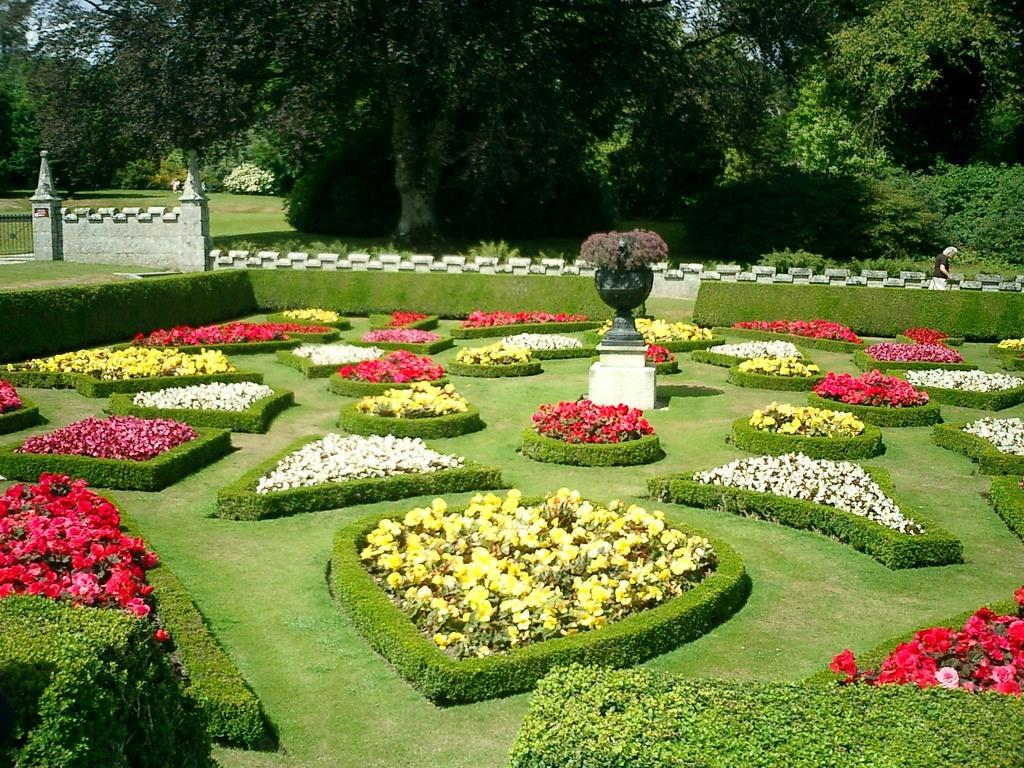What types of living organisms are at the bottom of the image? There are plants and flowers at the bottom of the image. What is located in the center of the image? There is a statue in the center of the image. What can be seen in the background of the image? There is a wall, a railing, a person, and trees in the background of the image. What is the name of the team that is playing in the image? There is no team or game present in the image. What does the image smell like? The image does not have a smell, as it is a visual representation. 